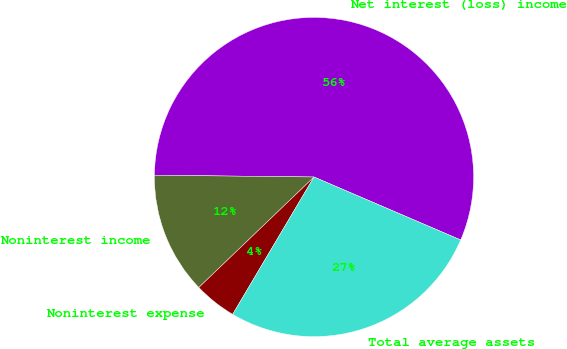Convert chart to OTSL. <chart><loc_0><loc_0><loc_500><loc_500><pie_chart><fcel>Net interest (loss) income<fcel>Noninterest income<fcel>Noninterest expense<fcel>Total average assets<nl><fcel>56.28%<fcel>12.35%<fcel>4.32%<fcel>27.06%<nl></chart> 